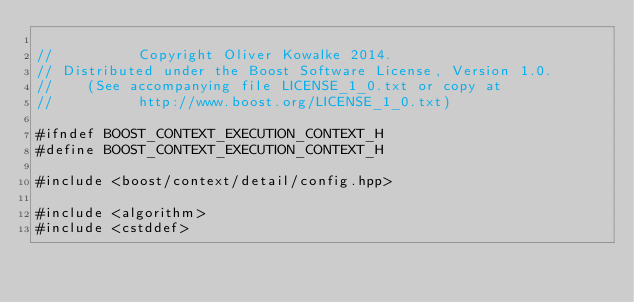Convert code to text. <code><loc_0><loc_0><loc_500><loc_500><_C++_>
//          Copyright Oliver Kowalke 2014.
// Distributed under the Boost Software License, Version 1.0.
//    (See accompanying file LICENSE_1_0.txt or copy at
//          http://www.boost.org/LICENSE_1_0.txt)

#ifndef BOOST_CONTEXT_EXECUTION_CONTEXT_H
#define BOOST_CONTEXT_EXECUTION_CONTEXT_H

#include <boost/context/detail/config.hpp>

#include <algorithm>
#include <cstddef></code> 